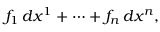Convert formula to latex. <formula><loc_0><loc_0><loc_500><loc_500>f _ { 1 } \, d x ^ { 1 } + \cdots + f _ { n } \, d x ^ { n } ,</formula> 